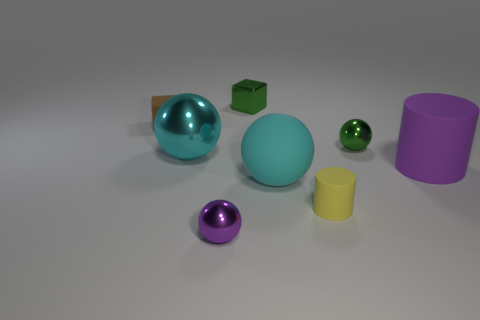What is the color of the other big sphere that is made of the same material as the purple sphere?
Give a very brief answer. Cyan. Is the number of small green spheres greater than the number of large yellow cylinders?
Your answer should be very brief. Yes. How many things are either small shiny things behind the yellow object or big blue matte cubes?
Your response must be concise. 2. Is there a green thing that has the same size as the matte cube?
Offer a very short reply. Yes. Is the number of cylinders less than the number of green rubber things?
Provide a short and direct response. No. How many balls are small metal things or purple metallic objects?
Make the answer very short. 2. How many small metallic objects have the same color as the tiny shiny block?
Offer a very short reply. 1. What is the size of the thing that is both on the right side of the brown rubber block and left of the small purple metallic sphere?
Give a very brief answer. Large. Is the number of large cyan metallic things that are left of the brown block less than the number of cyan rubber objects?
Provide a succinct answer. Yes. Is the small purple sphere made of the same material as the green ball?
Provide a succinct answer. Yes. 